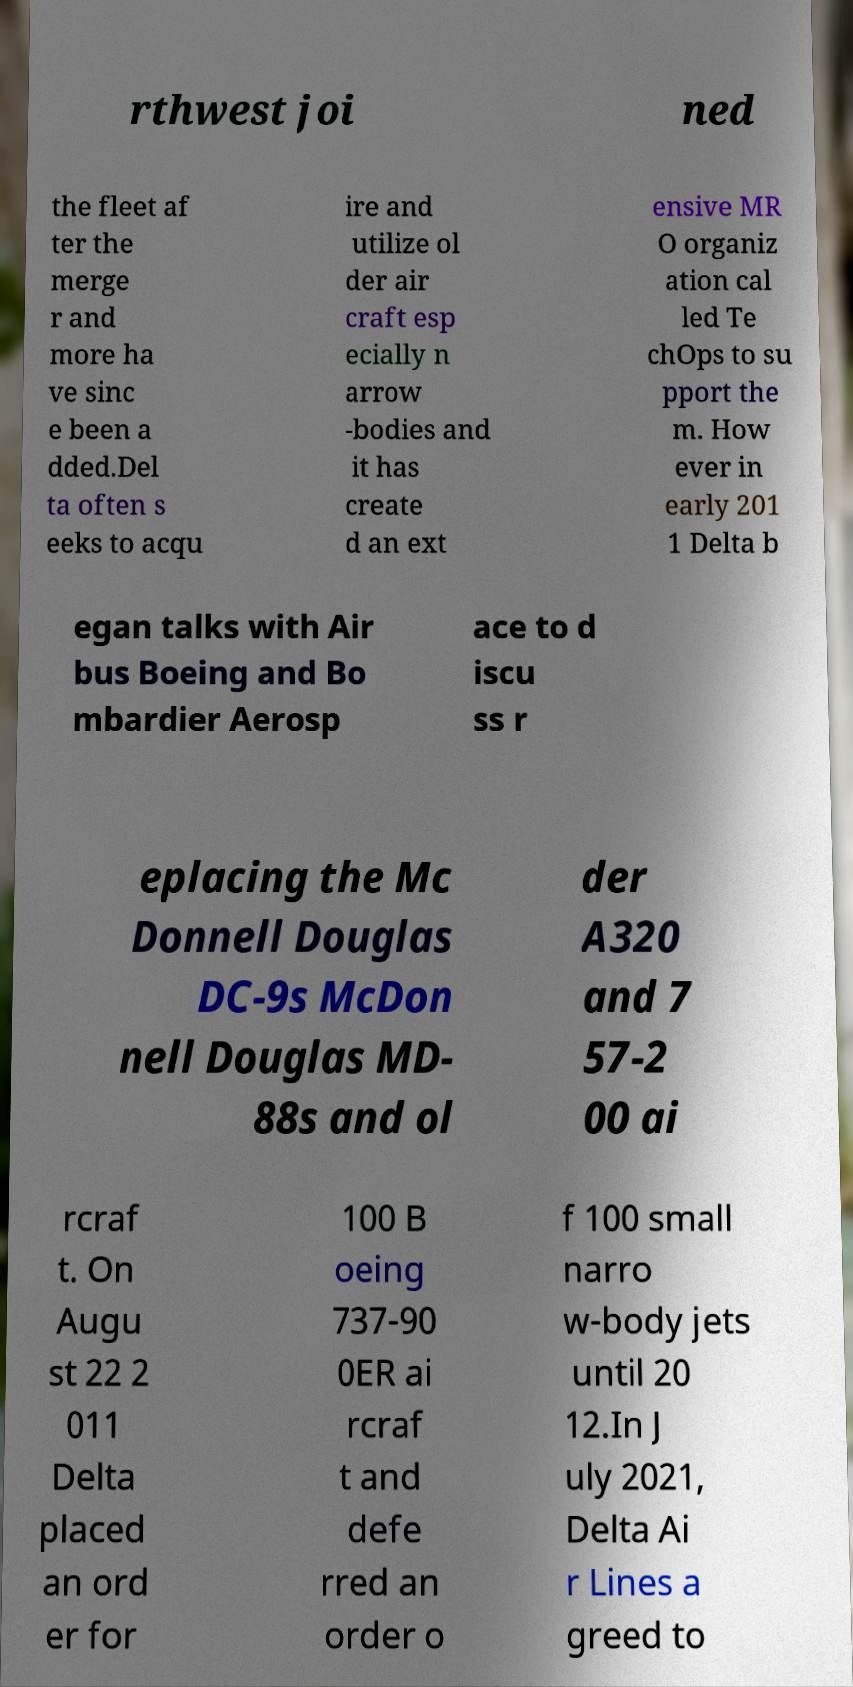Could you assist in decoding the text presented in this image and type it out clearly? rthwest joi ned the fleet af ter the merge r and more ha ve sinc e been a dded.Del ta often s eeks to acqu ire and utilize ol der air craft esp ecially n arrow -bodies and it has create d an ext ensive MR O organiz ation cal led Te chOps to su pport the m. How ever in early 201 1 Delta b egan talks with Air bus Boeing and Bo mbardier Aerosp ace to d iscu ss r eplacing the Mc Donnell Douglas DC-9s McDon nell Douglas MD- 88s and ol der A320 and 7 57-2 00 ai rcraf t. On Augu st 22 2 011 Delta placed an ord er for 100 B oeing 737-90 0ER ai rcraf t and defe rred an order o f 100 small narro w-body jets until 20 12.In J uly 2021, Delta Ai r Lines a greed to 